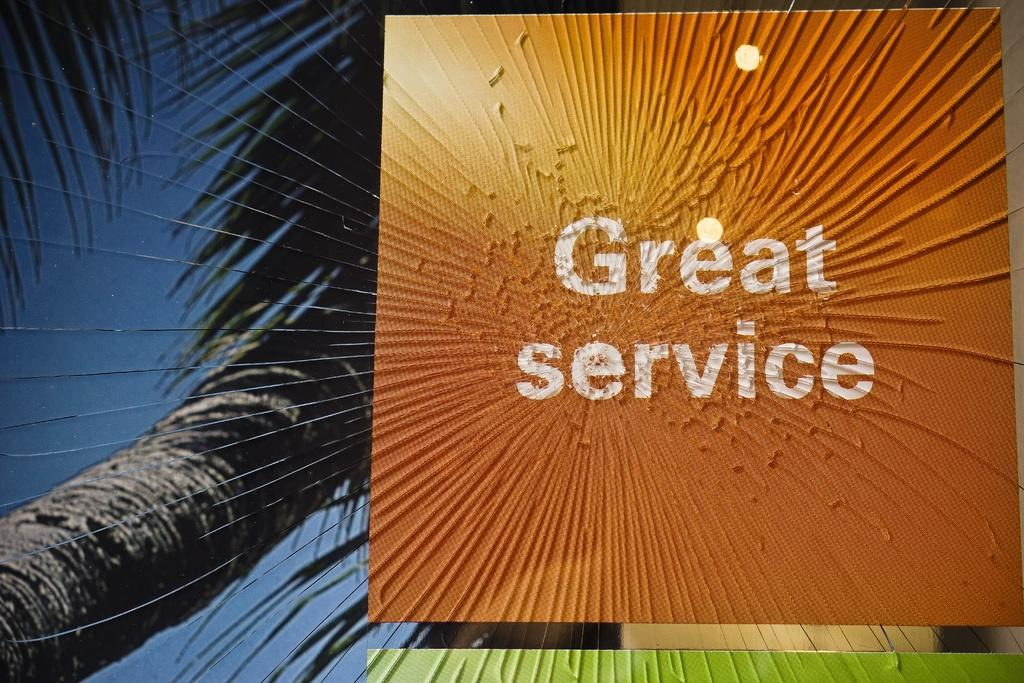What type of image is being described? The image is a poster. What is the main object in the foreground of the poster? There is an orange box in the foreground of the poster. What is written on the orange box? The text "GREAT SERVICE" is written on the orange box. What can be seen in the background of the poster? There is a tree and the sky visible in the background of the poster. How many branches can be seen on the bee in the image? There is no bee present in the image, so there are no branches to count. 